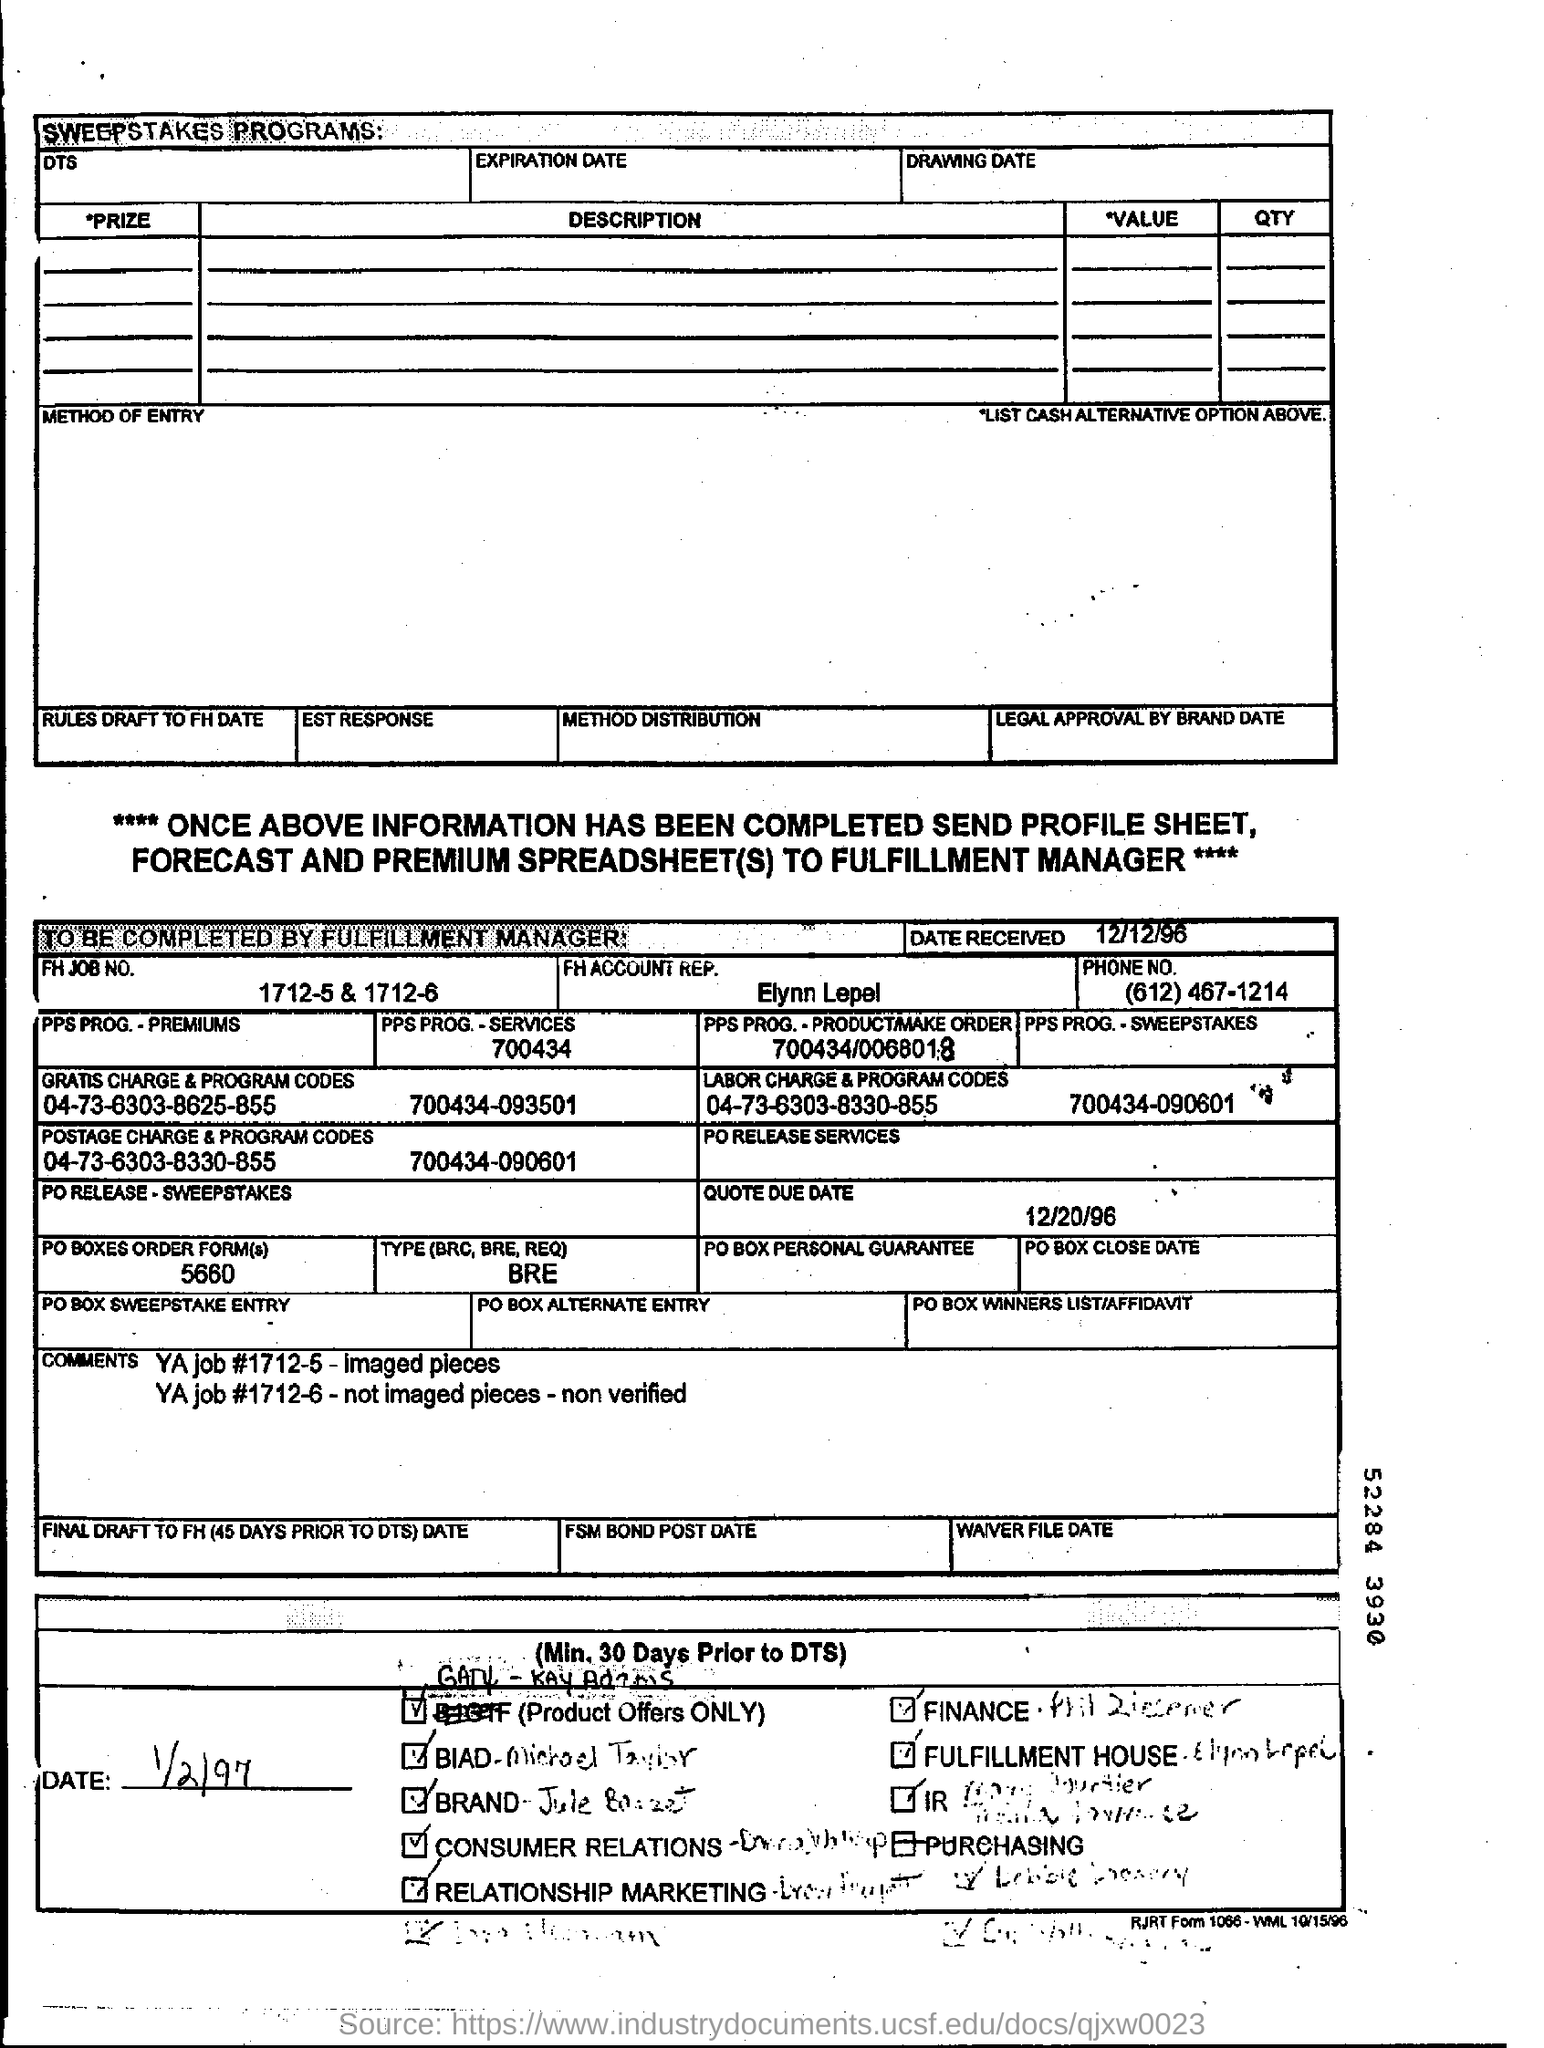Draw attention to some important aspects in this diagram. The phone number of Elynn Lepel is (612) 467-1214. The FH job number given in the form is 1712-5 and 1715-6. The date received as mentioned in the form is December 12, 1996. The quote due date provided in the form is 12/20/96. Elynn Lepel is the FH account representative mentioned in the form. 